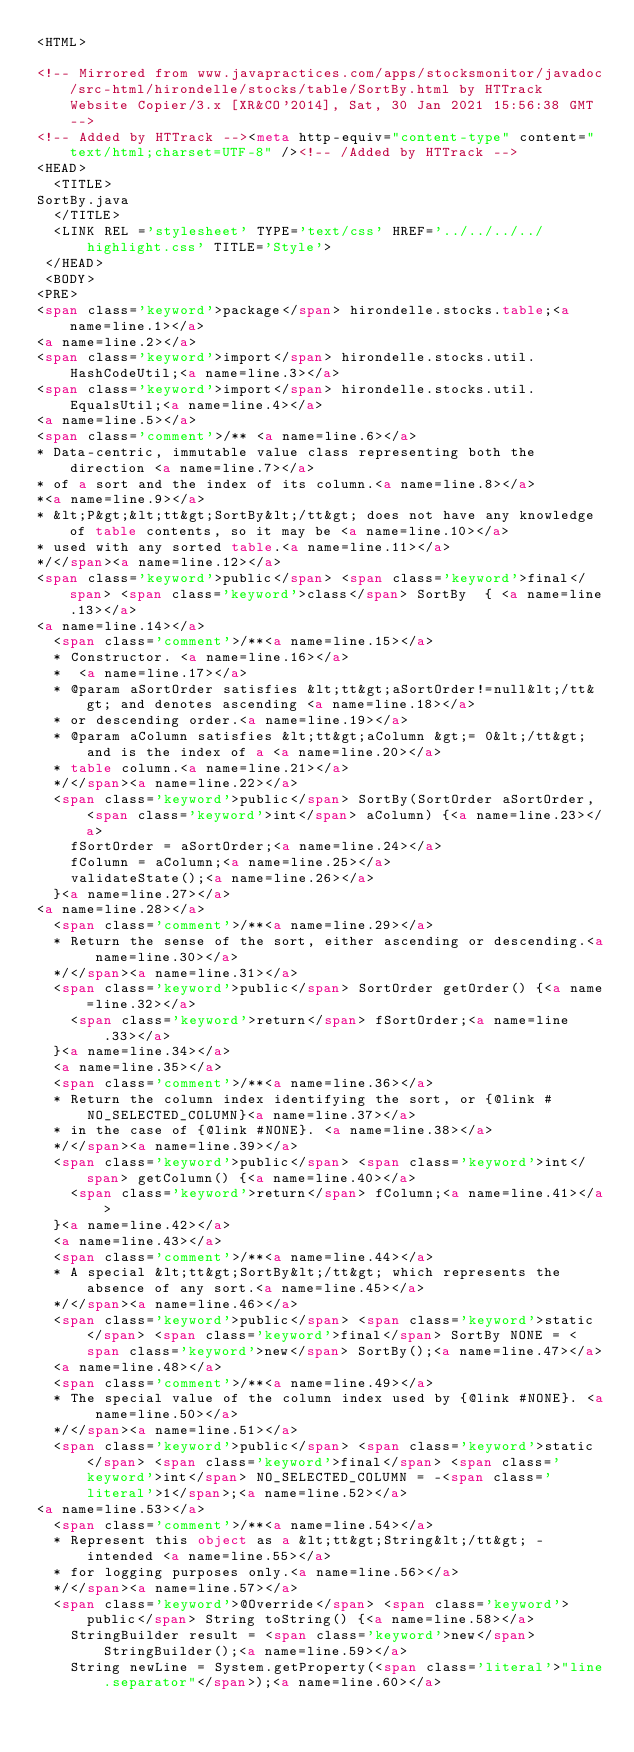<code> <loc_0><loc_0><loc_500><loc_500><_HTML_><HTML>
 
<!-- Mirrored from www.javapractices.com/apps/stocksmonitor/javadoc/src-html/hirondelle/stocks/table/SortBy.html by HTTrack Website Copier/3.x [XR&CO'2014], Sat, 30 Jan 2021 15:56:38 GMT -->
<!-- Added by HTTrack --><meta http-equiv="content-type" content="text/html;charset=UTF-8" /><!-- /Added by HTTrack -->
<HEAD>
  <TITLE>
SortBy.java
  </TITLE>
  <LINK REL ='stylesheet' TYPE='text/css' HREF='../../../../highlight.css' TITLE='Style'>
 </HEAD>
 <BODY>
<PRE>
<span class='keyword'>package</span> hirondelle.stocks.table;<a name=line.1></a>
<a name=line.2></a>
<span class='keyword'>import</span> hirondelle.stocks.util.HashCodeUtil;<a name=line.3></a>
<span class='keyword'>import</span> hirondelle.stocks.util.EqualsUtil;<a name=line.4></a>
<a name=line.5></a>
<span class='comment'>/** <a name=line.6></a>
* Data-centric, immutable value class representing both the direction <a name=line.7></a>
* of a sort and the index of its column.<a name=line.8></a>
*<a name=line.9></a>
* &lt;P&gt;&lt;tt&gt;SortBy&lt;/tt&gt; does not have any knowledge of table contents, so it may be <a name=line.10></a>
* used with any sorted table.<a name=line.11></a>
*/</span><a name=line.12></a>
<span class='keyword'>public</span> <span class='keyword'>final</span> <span class='keyword'>class</span> SortBy  { <a name=line.13></a>
<a name=line.14></a>
  <span class='comment'>/**<a name=line.15></a>
  * Constructor. <a name=line.16></a>
  *  <a name=line.17></a>
  * @param aSortOrder satisfies &lt;tt&gt;aSortOrder!=null&lt;/tt&gt; and denotes ascending <a name=line.18></a>
  * or descending order.<a name=line.19></a>
  * @param aColumn satisfies &lt;tt&gt;aColumn &gt;= 0&lt;/tt&gt; and is the index of a <a name=line.20></a>
  * table column.<a name=line.21></a>
  */</span><a name=line.22></a>
  <span class='keyword'>public</span> SortBy(SortOrder aSortOrder, <span class='keyword'>int</span> aColumn) {<a name=line.23></a>
    fSortOrder = aSortOrder;<a name=line.24></a>
    fColumn = aColumn;<a name=line.25></a>
    validateState();<a name=line.26></a>
  }<a name=line.27></a>
<a name=line.28></a>
  <span class='comment'>/**<a name=line.29></a>
  * Return the sense of the sort, either ascending or descending.<a name=line.30></a>
  */</span><a name=line.31></a>
  <span class='keyword'>public</span> SortOrder getOrder() {<a name=line.32></a>
    <span class='keyword'>return</span> fSortOrder;<a name=line.33></a>
  }<a name=line.34></a>
  <a name=line.35></a>
  <span class='comment'>/**<a name=line.36></a>
  * Return the column index identifying the sort, or {@link #NO_SELECTED_COLUMN}<a name=line.37></a>
  * in the case of {@link #NONE}. <a name=line.38></a>
  */</span><a name=line.39></a>
  <span class='keyword'>public</span> <span class='keyword'>int</span> getColumn() {<a name=line.40></a>
    <span class='keyword'>return</span> fColumn;<a name=line.41></a>
  }<a name=line.42></a>
  <a name=line.43></a>
  <span class='comment'>/**<a name=line.44></a>
  * A special &lt;tt&gt;SortBy&lt;/tt&gt; which represents the absence of any sort.<a name=line.45></a>
  */</span><a name=line.46></a>
  <span class='keyword'>public</span> <span class='keyword'>static</span> <span class='keyword'>final</span> SortBy NONE = <span class='keyword'>new</span> SortBy();<a name=line.47></a>
  <a name=line.48></a>
  <span class='comment'>/**<a name=line.49></a>
  * The special value of the column index used by {@link #NONE}. <a name=line.50></a>
  */</span><a name=line.51></a>
  <span class='keyword'>public</span> <span class='keyword'>static</span> <span class='keyword'>final</span> <span class='keyword'>int</span> NO_SELECTED_COLUMN = -<span class='literal'>1</span>;<a name=line.52></a>
<a name=line.53></a>
  <span class='comment'>/**<a name=line.54></a>
  * Represent this object as a &lt;tt&gt;String&lt;/tt&gt; - intended <a name=line.55></a>
  * for logging purposes only.<a name=line.56></a>
  */</span><a name=line.57></a>
  <span class='keyword'>@Override</span> <span class='keyword'>public</span> String toString() {<a name=line.58></a>
    StringBuilder result = <span class='keyword'>new</span> StringBuilder();<a name=line.59></a>
    String newLine = System.getProperty(<span class='literal'>"line.separator"</span>);<a name=line.60></a></code> 